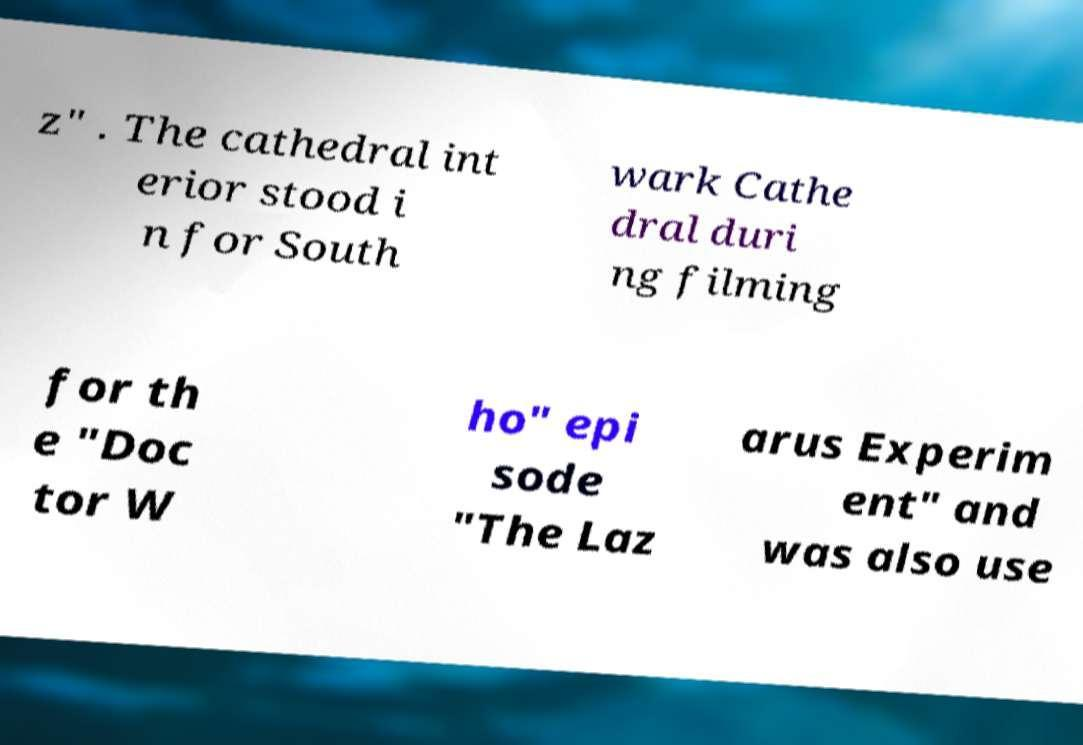Can you read and provide the text displayed in the image?This photo seems to have some interesting text. Can you extract and type it out for me? z" . The cathedral int erior stood i n for South wark Cathe dral duri ng filming for th e "Doc tor W ho" epi sode "The Laz arus Experim ent" and was also use 